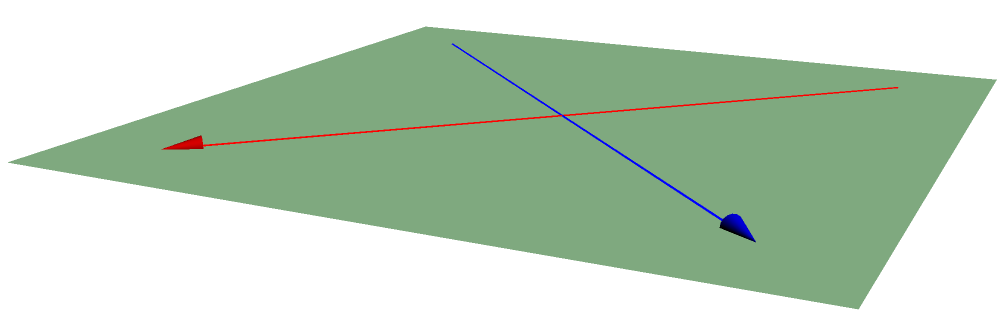In a garment factory, two conveyor belts intersect on the factory floor as shown in the diagram. The belts are oriented perpendicular to each other when viewed from above. If you were to calculate the angle $\theta$ between these conveyor belts in three-dimensional space, what would it be? To solve this problem, we need to consider the three-dimensional nature of the setup:

1) The conveyor belts are on the same plane (the factory floor), which simplifies our calculation.

2) When viewed from above, the belts form a right angle (90°).

3) In three-dimensional space, the angle between two lines or planes is the same as the angle between their normal vectors.

4) Since the belts are on the same plane, their normal vectors are parallel to each other and perpendicular to the floor.

5) When two normal vectors are parallel, the angle between the original lines or planes is complementary to the angle between the normal vectors.

6) The angle between parallel vectors is 0°.

7) Therefore, the angle between the conveyor belts is:

   $$\theta = 90° - 0° = 90°$$

This means that even in three-dimensional space, the angle between the conveyor belts remains 90°.
Answer: 90° 